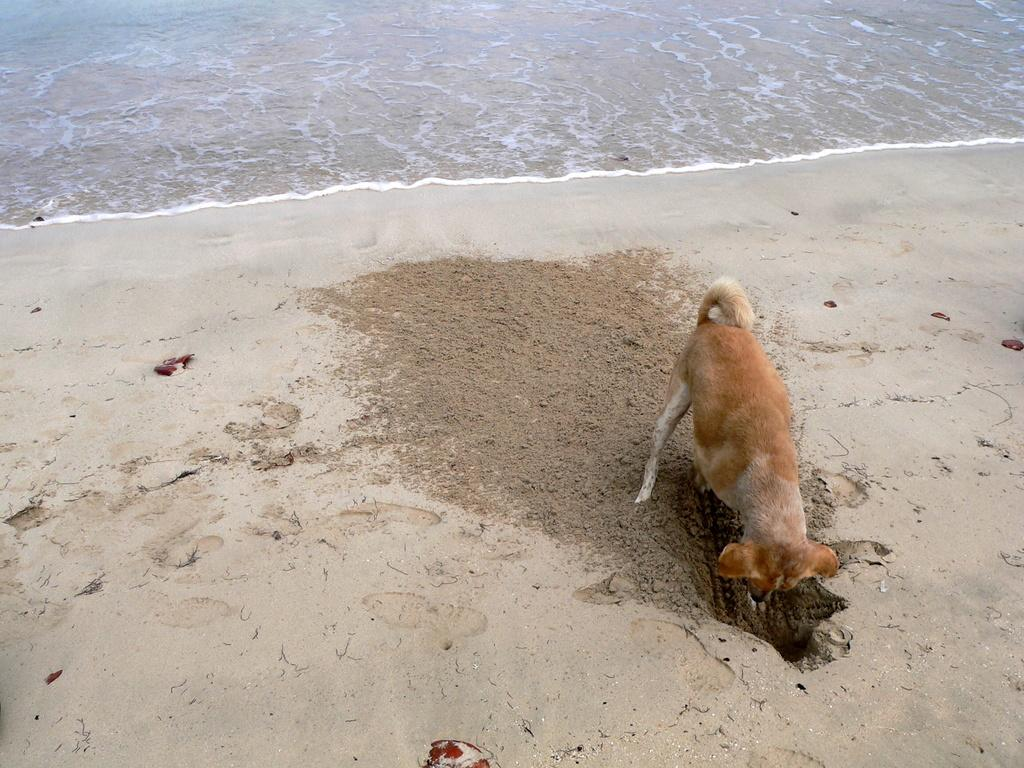What animal can be seen in the image? There is a dog in the image. What is the dog doing in the image? The dog is digging a pit. What can be seen in the background of the image? There is some water visible in the background of the image. What type of stone is the dog using to dig the pit in the image? There is no mention of a stone being used in the image; the dog is digging the pit with its paws. 